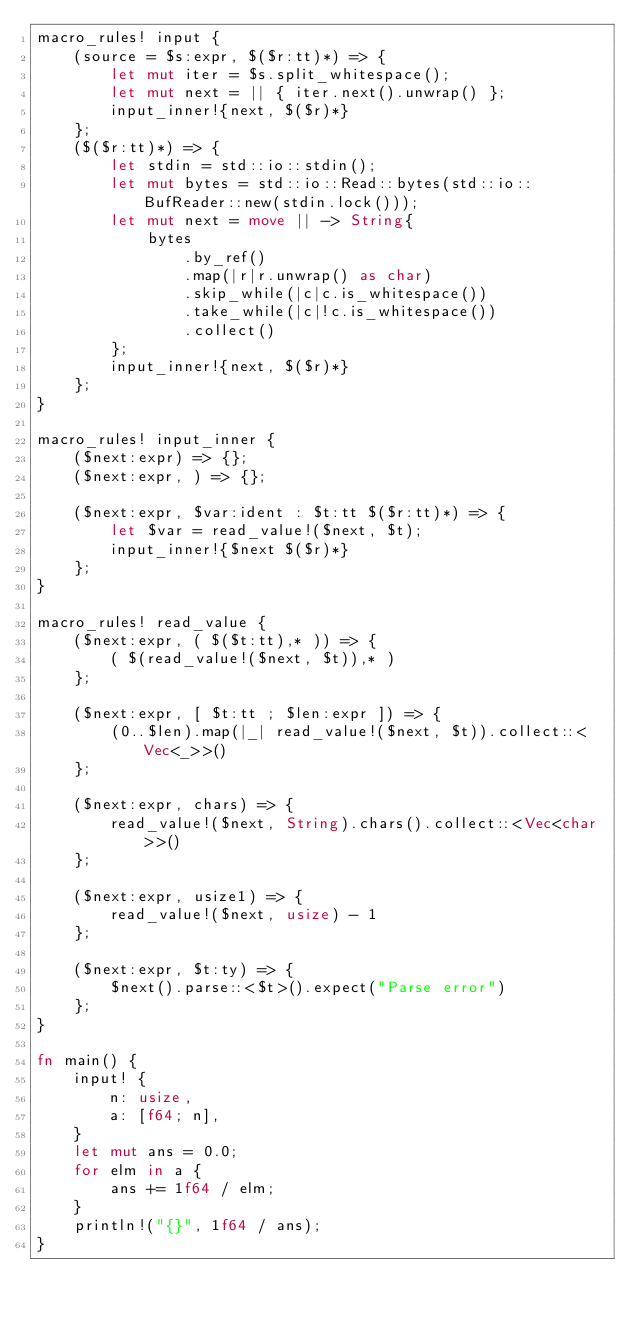Convert code to text. <code><loc_0><loc_0><loc_500><loc_500><_Rust_>macro_rules! input {
    (source = $s:expr, $($r:tt)*) => {
        let mut iter = $s.split_whitespace();
        let mut next = || { iter.next().unwrap() };
        input_inner!{next, $($r)*}
    };
    ($($r:tt)*) => {
        let stdin = std::io::stdin();
        let mut bytes = std::io::Read::bytes(std::io::BufReader::new(stdin.lock()));
        let mut next = move || -> String{
            bytes
                .by_ref()
                .map(|r|r.unwrap() as char)
                .skip_while(|c|c.is_whitespace())
                .take_while(|c|!c.is_whitespace())
                .collect()
        };
        input_inner!{next, $($r)*}
    };
}

macro_rules! input_inner {
    ($next:expr) => {};
    ($next:expr, ) => {};

    ($next:expr, $var:ident : $t:tt $($r:tt)*) => {
        let $var = read_value!($next, $t);
        input_inner!{$next $($r)*}
    };
}

macro_rules! read_value {
    ($next:expr, ( $($t:tt),* )) => {
        ( $(read_value!($next, $t)),* )
    };

    ($next:expr, [ $t:tt ; $len:expr ]) => {
        (0..$len).map(|_| read_value!($next, $t)).collect::<Vec<_>>()
    };

    ($next:expr, chars) => {
        read_value!($next, String).chars().collect::<Vec<char>>()
    };

    ($next:expr, usize1) => {
        read_value!($next, usize) - 1
    };

    ($next:expr, $t:ty) => {
        $next().parse::<$t>().expect("Parse error")
    };
}

fn main() {
    input! {
        n: usize,
        a: [f64; n],
    }
    let mut ans = 0.0;
    for elm in a {
        ans += 1f64 / elm;
    }
    println!("{}", 1f64 / ans);
}
</code> 